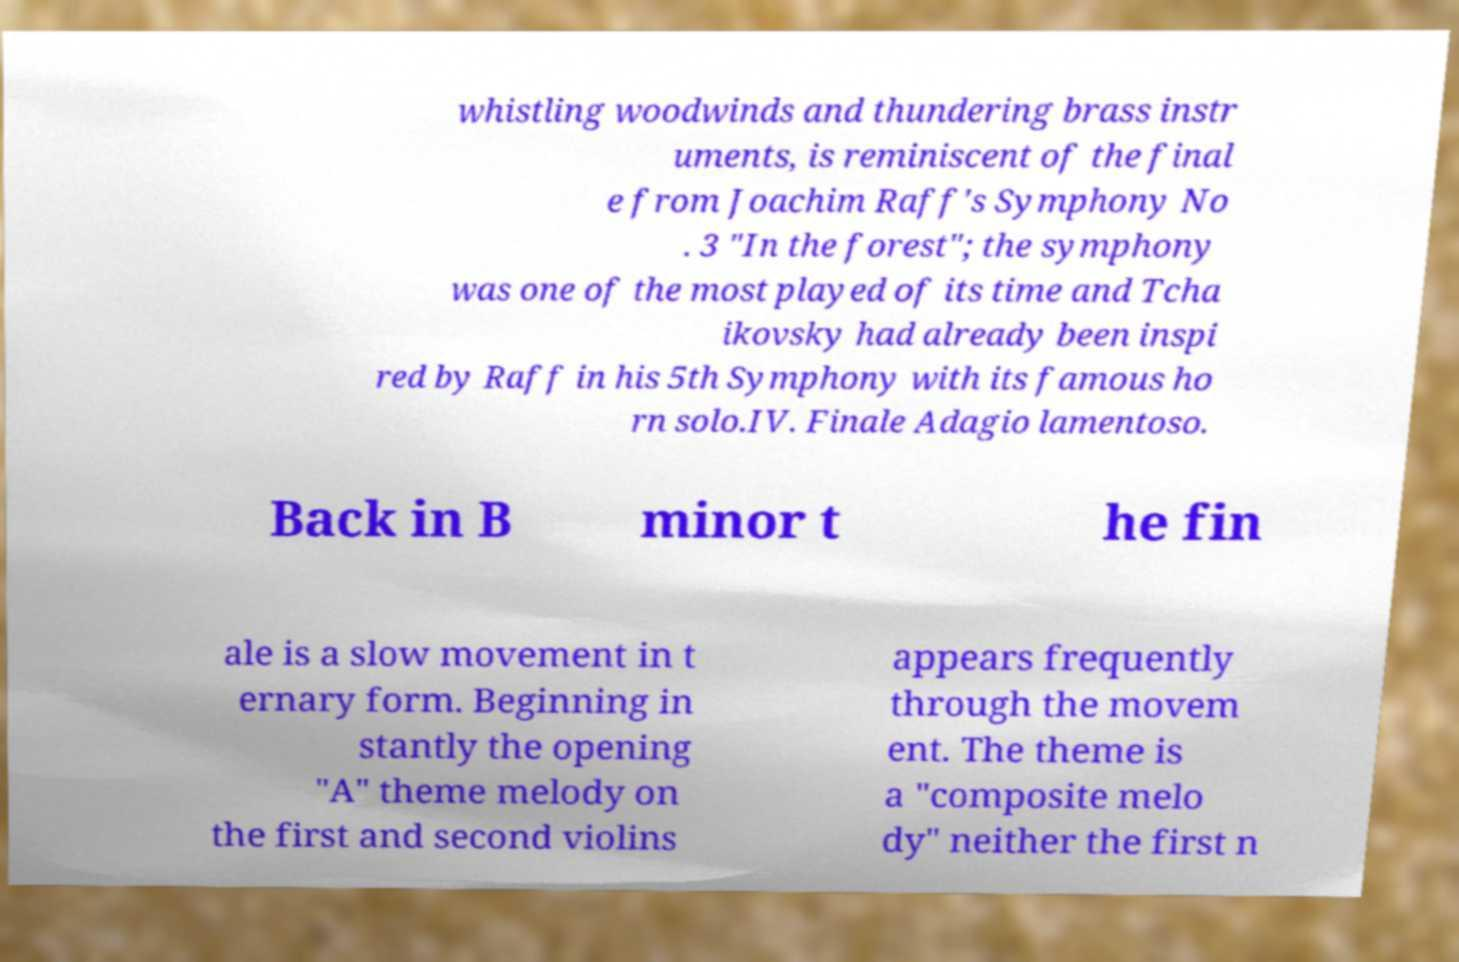There's text embedded in this image that I need extracted. Can you transcribe it verbatim? whistling woodwinds and thundering brass instr uments, is reminiscent of the final e from Joachim Raff's Symphony No . 3 "In the forest"; the symphony was one of the most played of its time and Tcha ikovsky had already been inspi red by Raff in his 5th Symphony with its famous ho rn solo.IV. Finale Adagio lamentoso. Back in B minor t he fin ale is a slow movement in t ernary form. Beginning in stantly the opening "A" theme melody on the first and second violins appears frequently through the movem ent. The theme is a "composite melo dy" neither the first n 